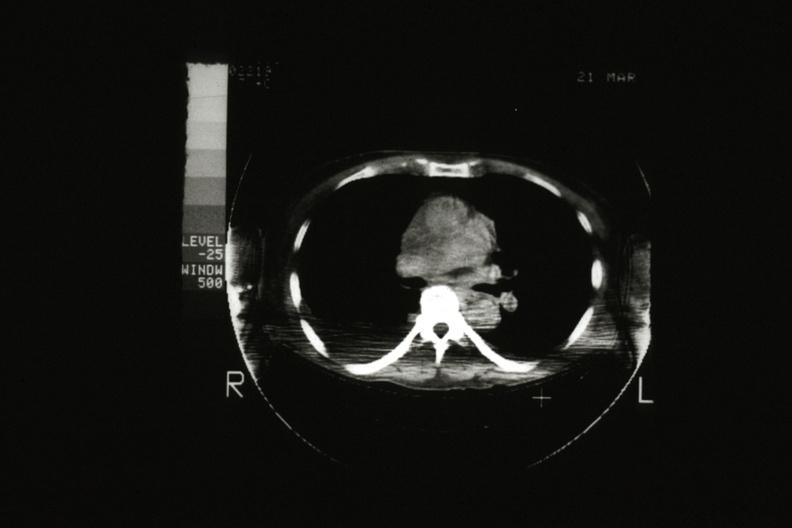does cat scan showing tumor mass invading superior vena ca?
Answer the question using a single word or phrase. Yes 